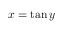<formula> <loc_0><loc_0><loc_500><loc_500>x = \tan y \,</formula> 